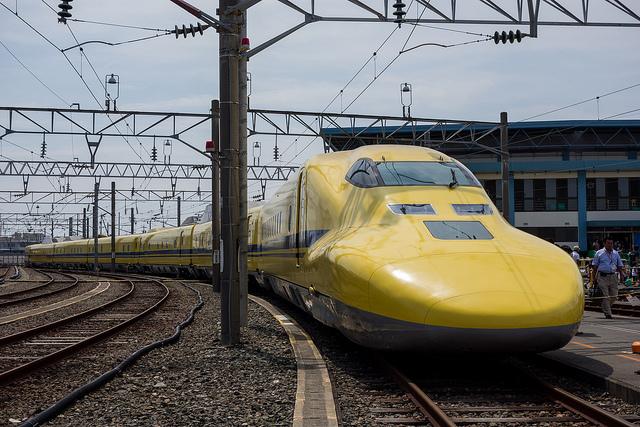What type of transportation is this?
Keep it brief. Train. Where is the train?
Quick response, please. On tracks. Is this a modern looking train?
Keep it brief. Yes. 